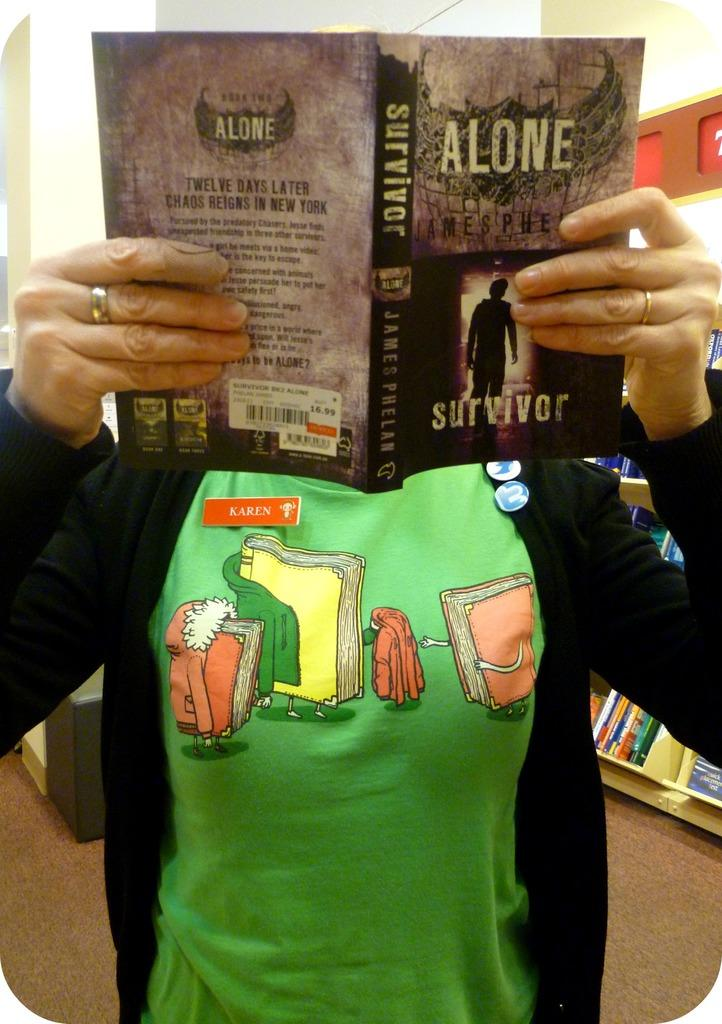<image>
Present a compact description of the photo's key features. A woman holding a book titled Alone, with the word Survivor at the bottom. 